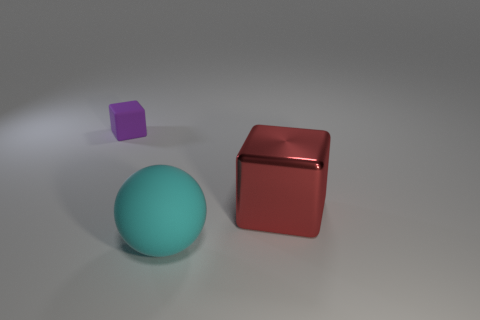Imagine these objects were part of a game. What could be the rules involving them? In a hypothetical game, these objects could be used in a tactile memory challenge where players are blindfolded and must identify the objects by touch. The cyan ball could represent one point, the shiny red cube could be worth two points, and the small purple cube could be a bonus item that doubles a player's score for a round. 